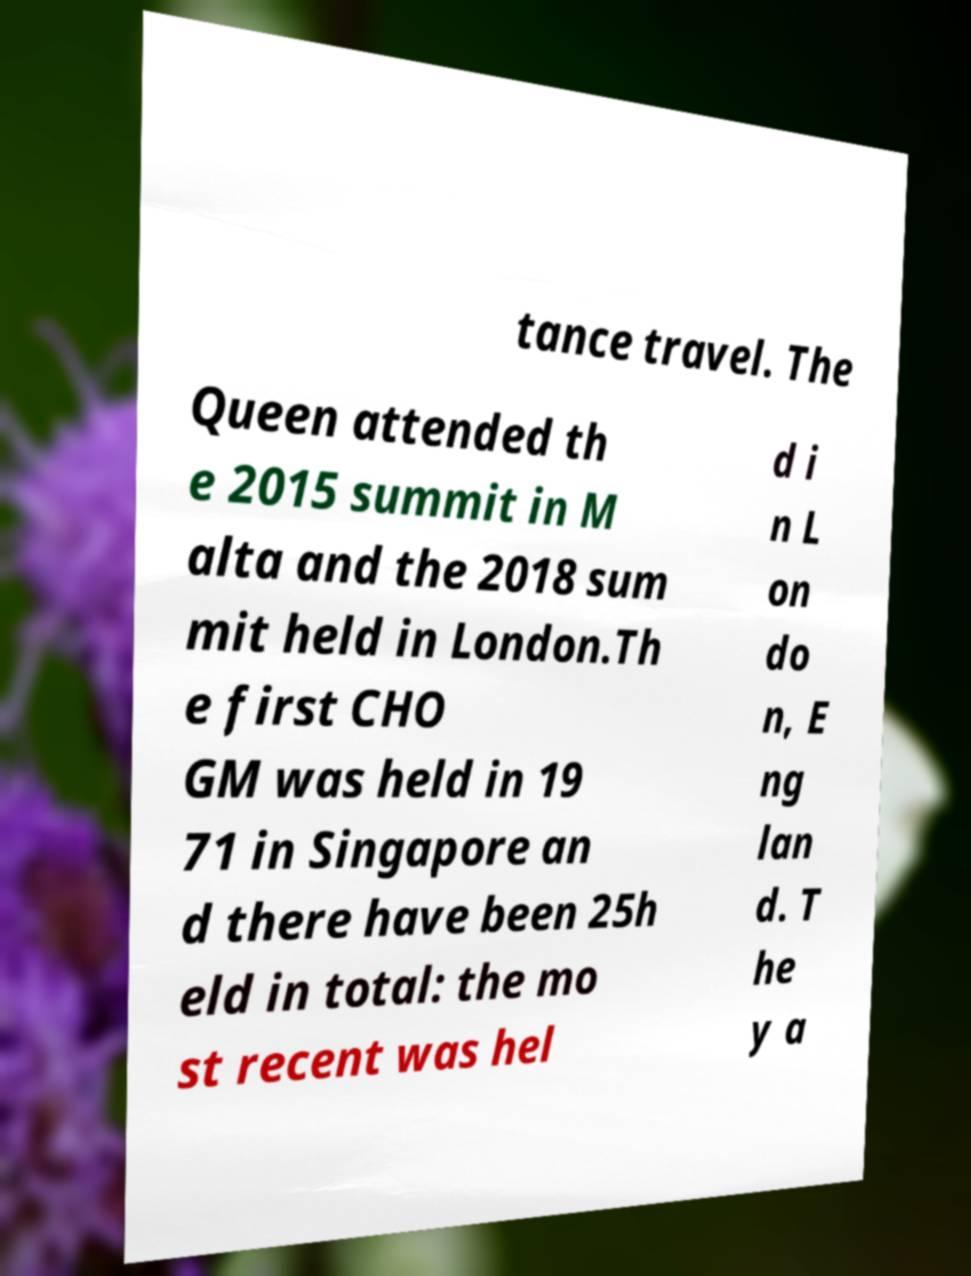There's text embedded in this image that I need extracted. Can you transcribe it verbatim? tance travel. The Queen attended th e 2015 summit in M alta and the 2018 sum mit held in London.Th e first CHO GM was held in 19 71 in Singapore an d there have been 25h eld in total: the mo st recent was hel d i n L on do n, E ng lan d. T he y a 